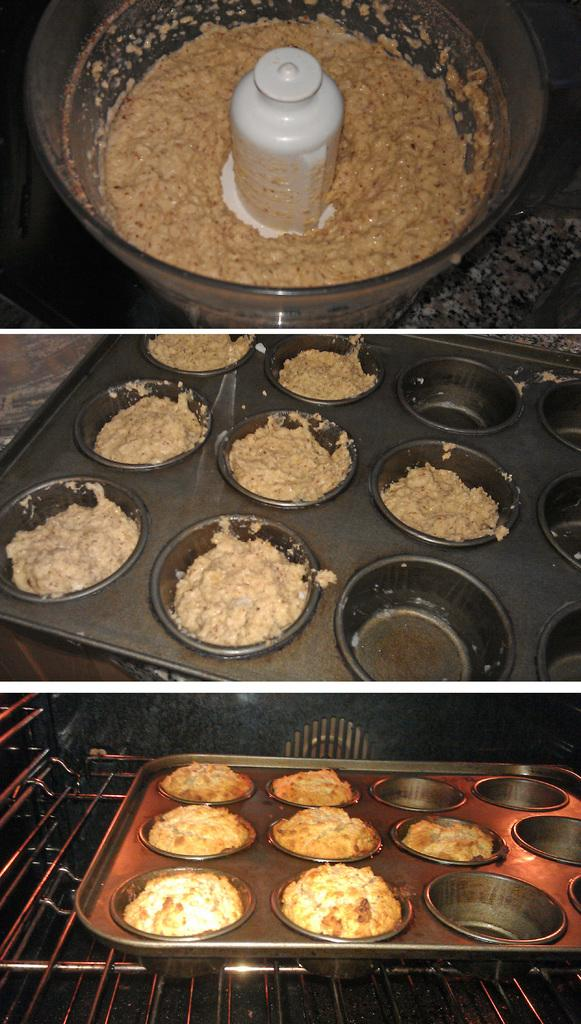What type of images are included in the collage? The collage contains food images. Can you describe the content of the collage in more detail? The collage is a collection of various food images. What type of dress is being worn by the produce in the image? There is no produce or dress present in the image, as it only contains a collage of food images. 